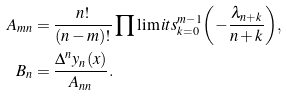Convert formula to latex. <formula><loc_0><loc_0><loc_500><loc_500>A _ { m n } & = \frac { n ! } { ( n - m ) ! } \prod \lim i t s _ { k = 0 } ^ { m - 1 } { \left ( { - \frac { { \lambda _ { n + k } } } { n + k } } \right ) } , \\ B _ { n } & = \frac { \Delta ^ { n } y _ { n } ( x ) } { { A _ { n n } } } .</formula> 